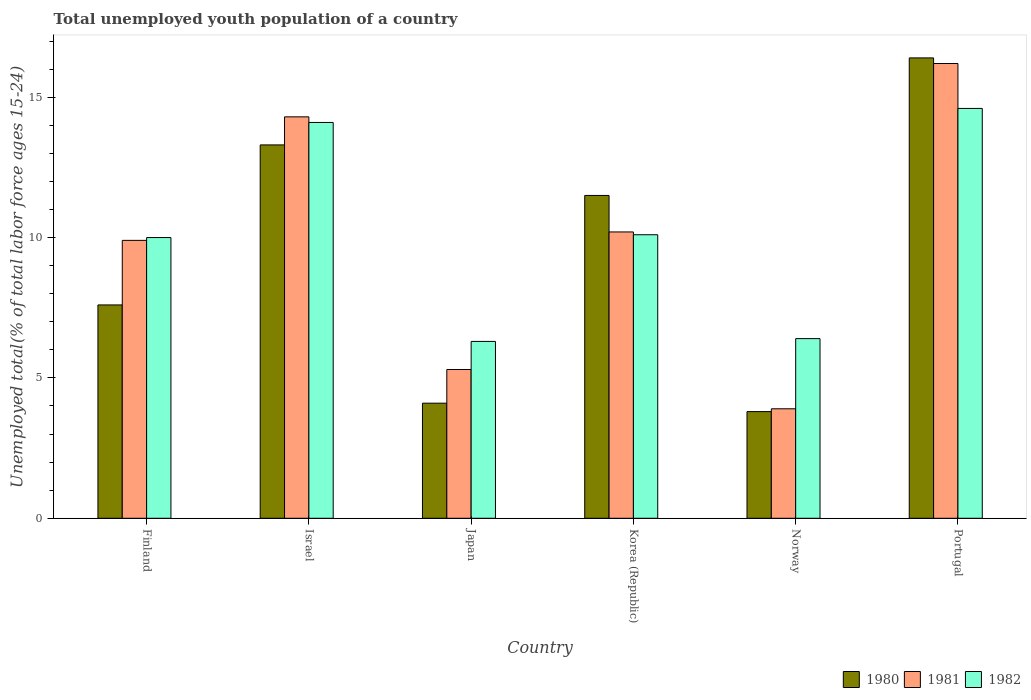How many different coloured bars are there?
Offer a terse response. 3. Are the number of bars on each tick of the X-axis equal?
Offer a terse response. Yes. How many bars are there on the 5th tick from the left?
Your answer should be very brief. 3. How many bars are there on the 1st tick from the right?
Your response must be concise. 3. What is the label of the 2nd group of bars from the left?
Provide a short and direct response. Israel. In how many cases, is the number of bars for a given country not equal to the number of legend labels?
Make the answer very short. 0. What is the percentage of total unemployed youth population of a country in 1982 in Norway?
Offer a terse response. 6.4. Across all countries, what is the maximum percentage of total unemployed youth population of a country in 1981?
Your answer should be compact. 16.2. Across all countries, what is the minimum percentage of total unemployed youth population of a country in 1981?
Your answer should be compact. 3.9. In which country was the percentage of total unemployed youth population of a country in 1980 maximum?
Provide a short and direct response. Portugal. What is the total percentage of total unemployed youth population of a country in 1980 in the graph?
Offer a very short reply. 56.7. What is the difference between the percentage of total unemployed youth population of a country in 1980 in Finland and that in Japan?
Give a very brief answer. 3.5. What is the difference between the percentage of total unemployed youth population of a country in 1980 in Norway and the percentage of total unemployed youth population of a country in 1982 in Portugal?
Make the answer very short. -10.8. What is the average percentage of total unemployed youth population of a country in 1982 per country?
Ensure brevity in your answer.  10.25. What is the difference between the percentage of total unemployed youth population of a country of/in 1982 and percentage of total unemployed youth population of a country of/in 1980 in Portugal?
Give a very brief answer. -1.8. In how many countries, is the percentage of total unemployed youth population of a country in 1981 greater than 1 %?
Offer a very short reply. 6. What is the ratio of the percentage of total unemployed youth population of a country in 1981 in Finland to that in Japan?
Provide a short and direct response. 1.87. Is the difference between the percentage of total unemployed youth population of a country in 1982 in Finland and Portugal greater than the difference between the percentage of total unemployed youth population of a country in 1980 in Finland and Portugal?
Make the answer very short. Yes. What is the difference between the highest and the second highest percentage of total unemployed youth population of a country in 1980?
Give a very brief answer. 4.9. What is the difference between the highest and the lowest percentage of total unemployed youth population of a country in 1981?
Provide a short and direct response. 12.3. In how many countries, is the percentage of total unemployed youth population of a country in 1980 greater than the average percentage of total unemployed youth population of a country in 1980 taken over all countries?
Your answer should be very brief. 3. What does the 1st bar from the left in Japan represents?
Keep it short and to the point. 1980. Is it the case that in every country, the sum of the percentage of total unemployed youth population of a country in 1982 and percentage of total unemployed youth population of a country in 1980 is greater than the percentage of total unemployed youth population of a country in 1981?
Your answer should be compact. Yes. How many bars are there?
Your answer should be very brief. 18. How many countries are there in the graph?
Keep it short and to the point. 6. Does the graph contain grids?
Provide a succinct answer. No. How many legend labels are there?
Offer a very short reply. 3. How are the legend labels stacked?
Offer a terse response. Horizontal. What is the title of the graph?
Provide a succinct answer. Total unemployed youth population of a country. Does "1990" appear as one of the legend labels in the graph?
Your answer should be very brief. No. What is the label or title of the Y-axis?
Ensure brevity in your answer.  Unemployed total(% of total labor force ages 15-24). What is the Unemployed total(% of total labor force ages 15-24) in 1980 in Finland?
Give a very brief answer. 7.6. What is the Unemployed total(% of total labor force ages 15-24) in 1981 in Finland?
Provide a succinct answer. 9.9. What is the Unemployed total(% of total labor force ages 15-24) in 1982 in Finland?
Give a very brief answer. 10. What is the Unemployed total(% of total labor force ages 15-24) in 1980 in Israel?
Your answer should be very brief. 13.3. What is the Unemployed total(% of total labor force ages 15-24) of 1981 in Israel?
Provide a short and direct response. 14.3. What is the Unemployed total(% of total labor force ages 15-24) in 1982 in Israel?
Provide a short and direct response. 14.1. What is the Unemployed total(% of total labor force ages 15-24) in 1980 in Japan?
Offer a terse response. 4.1. What is the Unemployed total(% of total labor force ages 15-24) of 1981 in Japan?
Ensure brevity in your answer.  5.3. What is the Unemployed total(% of total labor force ages 15-24) in 1982 in Japan?
Provide a short and direct response. 6.3. What is the Unemployed total(% of total labor force ages 15-24) in 1980 in Korea (Republic)?
Keep it short and to the point. 11.5. What is the Unemployed total(% of total labor force ages 15-24) in 1981 in Korea (Republic)?
Provide a short and direct response. 10.2. What is the Unemployed total(% of total labor force ages 15-24) in 1982 in Korea (Republic)?
Your response must be concise. 10.1. What is the Unemployed total(% of total labor force ages 15-24) in 1980 in Norway?
Your answer should be compact. 3.8. What is the Unemployed total(% of total labor force ages 15-24) in 1981 in Norway?
Make the answer very short. 3.9. What is the Unemployed total(% of total labor force ages 15-24) in 1982 in Norway?
Your answer should be very brief. 6.4. What is the Unemployed total(% of total labor force ages 15-24) of 1980 in Portugal?
Ensure brevity in your answer.  16.4. What is the Unemployed total(% of total labor force ages 15-24) of 1981 in Portugal?
Your answer should be compact. 16.2. What is the Unemployed total(% of total labor force ages 15-24) of 1982 in Portugal?
Offer a very short reply. 14.6. Across all countries, what is the maximum Unemployed total(% of total labor force ages 15-24) of 1980?
Your answer should be very brief. 16.4. Across all countries, what is the maximum Unemployed total(% of total labor force ages 15-24) in 1981?
Ensure brevity in your answer.  16.2. Across all countries, what is the maximum Unemployed total(% of total labor force ages 15-24) in 1982?
Keep it short and to the point. 14.6. Across all countries, what is the minimum Unemployed total(% of total labor force ages 15-24) in 1980?
Your answer should be compact. 3.8. Across all countries, what is the minimum Unemployed total(% of total labor force ages 15-24) in 1981?
Your answer should be very brief. 3.9. Across all countries, what is the minimum Unemployed total(% of total labor force ages 15-24) of 1982?
Offer a very short reply. 6.3. What is the total Unemployed total(% of total labor force ages 15-24) in 1980 in the graph?
Offer a terse response. 56.7. What is the total Unemployed total(% of total labor force ages 15-24) of 1981 in the graph?
Give a very brief answer. 59.8. What is the total Unemployed total(% of total labor force ages 15-24) in 1982 in the graph?
Your response must be concise. 61.5. What is the difference between the Unemployed total(% of total labor force ages 15-24) of 1980 in Finland and that in Israel?
Provide a short and direct response. -5.7. What is the difference between the Unemployed total(% of total labor force ages 15-24) of 1980 in Finland and that in Japan?
Give a very brief answer. 3.5. What is the difference between the Unemployed total(% of total labor force ages 15-24) of 1981 in Finland and that in Japan?
Make the answer very short. 4.6. What is the difference between the Unemployed total(% of total labor force ages 15-24) of 1982 in Finland and that in Japan?
Keep it short and to the point. 3.7. What is the difference between the Unemployed total(% of total labor force ages 15-24) in 1981 in Finland and that in Norway?
Your answer should be compact. 6. What is the difference between the Unemployed total(% of total labor force ages 15-24) in 1980 in Finland and that in Portugal?
Your answer should be very brief. -8.8. What is the difference between the Unemployed total(% of total labor force ages 15-24) in 1980 in Israel and that in Japan?
Keep it short and to the point. 9.2. What is the difference between the Unemployed total(% of total labor force ages 15-24) in 1981 in Israel and that in Japan?
Your response must be concise. 9. What is the difference between the Unemployed total(% of total labor force ages 15-24) in 1980 in Israel and that in Korea (Republic)?
Make the answer very short. 1.8. What is the difference between the Unemployed total(% of total labor force ages 15-24) of 1982 in Israel and that in Korea (Republic)?
Provide a short and direct response. 4. What is the difference between the Unemployed total(% of total labor force ages 15-24) in 1980 in Israel and that in Norway?
Give a very brief answer. 9.5. What is the difference between the Unemployed total(% of total labor force ages 15-24) of 1981 in Israel and that in Norway?
Ensure brevity in your answer.  10.4. What is the difference between the Unemployed total(% of total labor force ages 15-24) of 1982 in Israel and that in Norway?
Make the answer very short. 7.7. What is the difference between the Unemployed total(% of total labor force ages 15-24) of 1980 in Japan and that in Korea (Republic)?
Provide a succinct answer. -7.4. What is the difference between the Unemployed total(% of total labor force ages 15-24) in 1981 in Japan and that in Korea (Republic)?
Offer a terse response. -4.9. What is the difference between the Unemployed total(% of total labor force ages 15-24) in 1982 in Japan and that in Korea (Republic)?
Offer a very short reply. -3.8. What is the difference between the Unemployed total(% of total labor force ages 15-24) in 1980 in Japan and that in Portugal?
Keep it short and to the point. -12.3. What is the difference between the Unemployed total(% of total labor force ages 15-24) of 1982 in Japan and that in Portugal?
Provide a short and direct response. -8.3. What is the difference between the Unemployed total(% of total labor force ages 15-24) in 1981 in Korea (Republic) and that in Norway?
Make the answer very short. 6.3. What is the difference between the Unemployed total(% of total labor force ages 15-24) of 1982 in Korea (Republic) and that in Portugal?
Your answer should be very brief. -4.5. What is the difference between the Unemployed total(% of total labor force ages 15-24) in 1980 in Norway and that in Portugal?
Make the answer very short. -12.6. What is the difference between the Unemployed total(% of total labor force ages 15-24) of 1981 in Norway and that in Portugal?
Give a very brief answer. -12.3. What is the difference between the Unemployed total(% of total labor force ages 15-24) in 1980 in Finland and the Unemployed total(% of total labor force ages 15-24) in 1981 in Israel?
Give a very brief answer. -6.7. What is the difference between the Unemployed total(% of total labor force ages 15-24) in 1981 in Finland and the Unemployed total(% of total labor force ages 15-24) in 1982 in Israel?
Your answer should be very brief. -4.2. What is the difference between the Unemployed total(% of total labor force ages 15-24) in 1980 in Finland and the Unemployed total(% of total labor force ages 15-24) in 1981 in Japan?
Offer a very short reply. 2.3. What is the difference between the Unemployed total(% of total labor force ages 15-24) in 1981 in Finland and the Unemployed total(% of total labor force ages 15-24) in 1982 in Japan?
Your answer should be compact. 3.6. What is the difference between the Unemployed total(% of total labor force ages 15-24) of 1980 in Finland and the Unemployed total(% of total labor force ages 15-24) of 1981 in Korea (Republic)?
Offer a very short reply. -2.6. What is the difference between the Unemployed total(% of total labor force ages 15-24) of 1980 in Finland and the Unemployed total(% of total labor force ages 15-24) of 1982 in Korea (Republic)?
Make the answer very short. -2.5. What is the difference between the Unemployed total(% of total labor force ages 15-24) in 1980 in Finland and the Unemployed total(% of total labor force ages 15-24) in 1982 in Norway?
Keep it short and to the point. 1.2. What is the difference between the Unemployed total(% of total labor force ages 15-24) of 1981 in Finland and the Unemployed total(% of total labor force ages 15-24) of 1982 in Norway?
Offer a very short reply. 3.5. What is the difference between the Unemployed total(% of total labor force ages 15-24) in 1981 in Finland and the Unemployed total(% of total labor force ages 15-24) in 1982 in Portugal?
Your answer should be very brief. -4.7. What is the difference between the Unemployed total(% of total labor force ages 15-24) in 1980 in Israel and the Unemployed total(% of total labor force ages 15-24) in 1981 in Japan?
Your answer should be very brief. 8. What is the difference between the Unemployed total(% of total labor force ages 15-24) of 1980 in Israel and the Unemployed total(% of total labor force ages 15-24) of 1982 in Japan?
Provide a succinct answer. 7. What is the difference between the Unemployed total(% of total labor force ages 15-24) of 1980 in Israel and the Unemployed total(% of total labor force ages 15-24) of 1981 in Korea (Republic)?
Keep it short and to the point. 3.1. What is the difference between the Unemployed total(% of total labor force ages 15-24) of 1980 in Israel and the Unemployed total(% of total labor force ages 15-24) of 1982 in Korea (Republic)?
Offer a terse response. 3.2. What is the difference between the Unemployed total(% of total labor force ages 15-24) in 1980 in Israel and the Unemployed total(% of total labor force ages 15-24) in 1981 in Portugal?
Keep it short and to the point. -2.9. What is the difference between the Unemployed total(% of total labor force ages 15-24) of 1980 in Japan and the Unemployed total(% of total labor force ages 15-24) of 1982 in Korea (Republic)?
Make the answer very short. -6. What is the difference between the Unemployed total(% of total labor force ages 15-24) in 1981 in Japan and the Unemployed total(% of total labor force ages 15-24) in 1982 in Korea (Republic)?
Make the answer very short. -4.8. What is the difference between the Unemployed total(% of total labor force ages 15-24) in 1980 in Japan and the Unemployed total(% of total labor force ages 15-24) in 1981 in Norway?
Offer a terse response. 0.2. What is the difference between the Unemployed total(% of total labor force ages 15-24) of 1981 in Japan and the Unemployed total(% of total labor force ages 15-24) of 1982 in Norway?
Provide a short and direct response. -1.1. What is the difference between the Unemployed total(% of total labor force ages 15-24) of 1980 in Japan and the Unemployed total(% of total labor force ages 15-24) of 1981 in Portugal?
Offer a terse response. -12.1. What is the difference between the Unemployed total(% of total labor force ages 15-24) of 1980 in Japan and the Unemployed total(% of total labor force ages 15-24) of 1982 in Portugal?
Offer a terse response. -10.5. What is the difference between the Unemployed total(% of total labor force ages 15-24) of 1980 in Korea (Republic) and the Unemployed total(% of total labor force ages 15-24) of 1981 in Norway?
Your answer should be very brief. 7.6. What is the difference between the Unemployed total(% of total labor force ages 15-24) in 1980 in Korea (Republic) and the Unemployed total(% of total labor force ages 15-24) in 1982 in Norway?
Offer a very short reply. 5.1. What is the difference between the Unemployed total(% of total labor force ages 15-24) in 1980 in Norway and the Unemployed total(% of total labor force ages 15-24) in 1981 in Portugal?
Make the answer very short. -12.4. What is the difference between the Unemployed total(% of total labor force ages 15-24) of 1980 in Norway and the Unemployed total(% of total labor force ages 15-24) of 1982 in Portugal?
Your response must be concise. -10.8. What is the average Unemployed total(% of total labor force ages 15-24) in 1980 per country?
Offer a terse response. 9.45. What is the average Unemployed total(% of total labor force ages 15-24) of 1981 per country?
Your answer should be very brief. 9.97. What is the average Unemployed total(% of total labor force ages 15-24) of 1982 per country?
Your answer should be compact. 10.25. What is the difference between the Unemployed total(% of total labor force ages 15-24) in 1980 and Unemployed total(% of total labor force ages 15-24) in 1982 in Finland?
Your response must be concise. -2.4. What is the difference between the Unemployed total(% of total labor force ages 15-24) of 1980 and Unemployed total(% of total labor force ages 15-24) of 1981 in Israel?
Your response must be concise. -1. What is the difference between the Unemployed total(% of total labor force ages 15-24) of 1980 and Unemployed total(% of total labor force ages 15-24) of 1982 in Israel?
Offer a very short reply. -0.8. What is the difference between the Unemployed total(% of total labor force ages 15-24) of 1981 and Unemployed total(% of total labor force ages 15-24) of 1982 in Israel?
Your answer should be compact. 0.2. What is the difference between the Unemployed total(% of total labor force ages 15-24) in 1981 and Unemployed total(% of total labor force ages 15-24) in 1982 in Japan?
Provide a short and direct response. -1. What is the difference between the Unemployed total(% of total labor force ages 15-24) of 1980 and Unemployed total(% of total labor force ages 15-24) of 1981 in Korea (Republic)?
Make the answer very short. 1.3. What is the difference between the Unemployed total(% of total labor force ages 15-24) of 1981 and Unemployed total(% of total labor force ages 15-24) of 1982 in Korea (Republic)?
Your answer should be compact. 0.1. What is the difference between the Unemployed total(% of total labor force ages 15-24) in 1980 and Unemployed total(% of total labor force ages 15-24) in 1982 in Norway?
Your answer should be very brief. -2.6. What is the difference between the Unemployed total(% of total labor force ages 15-24) of 1981 and Unemployed total(% of total labor force ages 15-24) of 1982 in Portugal?
Make the answer very short. 1.6. What is the ratio of the Unemployed total(% of total labor force ages 15-24) of 1981 in Finland to that in Israel?
Ensure brevity in your answer.  0.69. What is the ratio of the Unemployed total(% of total labor force ages 15-24) in 1982 in Finland to that in Israel?
Your answer should be very brief. 0.71. What is the ratio of the Unemployed total(% of total labor force ages 15-24) of 1980 in Finland to that in Japan?
Keep it short and to the point. 1.85. What is the ratio of the Unemployed total(% of total labor force ages 15-24) of 1981 in Finland to that in Japan?
Ensure brevity in your answer.  1.87. What is the ratio of the Unemployed total(% of total labor force ages 15-24) of 1982 in Finland to that in Japan?
Offer a terse response. 1.59. What is the ratio of the Unemployed total(% of total labor force ages 15-24) in 1980 in Finland to that in Korea (Republic)?
Provide a short and direct response. 0.66. What is the ratio of the Unemployed total(% of total labor force ages 15-24) in 1981 in Finland to that in Korea (Republic)?
Make the answer very short. 0.97. What is the ratio of the Unemployed total(% of total labor force ages 15-24) of 1980 in Finland to that in Norway?
Make the answer very short. 2. What is the ratio of the Unemployed total(% of total labor force ages 15-24) in 1981 in Finland to that in Norway?
Your answer should be compact. 2.54. What is the ratio of the Unemployed total(% of total labor force ages 15-24) of 1982 in Finland to that in Norway?
Your answer should be compact. 1.56. What is the ratio of the Unemployed total(% of total labor force ages 15-24) of 1980 in Finland to that in Portugal?
Your response must be concise. 0.46. What is the ratio of the Unemployed total(% of total labor force ages 15-24) in 1981 in Finland to that in Portugal?
Ensure brevity in your answer.  0.61. What is the ratio of the Unemployed total(% of total labor force ages 15-24) of 1982 in Finland to that in Portugal?
Your answer should be very brief. 0.68. What is the ratio of the Unemployed total(% of total labor force ages 15-24) in 1980 in Israel to that in Japan?
Keep it short and to the point. 3.24. What is the ratio of the Unemployed total(% of total labor force ages 15-24) in 1981 in Israel to that in Japan?
Provide a succinct answer. 2.7. What is the ratio of the Unemployed total(% of total labor force ages 15-24) in 1982 in Israel to that in Japan?
Offer a terse response. 2.24. What is the ratio of the Unemployed total(% of total labor force ages 15-24) of 1980 in Israel to that in Korea (Republic)?
Provide a short and direct response. 1.16. What is the ratio of the Unemployed total(% of total labor force ages 15-24) of 1981 in Israel to that in Korea (Republic)?
Provide a succinct answer. 1.4. What is the ratio of the Unemployed total(% of total labor force ages 15-24) of 1982 in Israel to that in Korea (Republic)?
Keep it short and to the point. 1.4. What is the ratio of the Unemployed total(% of total labor force ages 15-24) of 1980 in Israel to that in Norway?
Ensure brevity in your answer.  3.5. What is the ratio of the Unemployed total(% of total labor force ages 15-24) of 1981 in Israel to that in Norway?
Ensure brevity in your answer.  3.67. What is the ratio of the Unemployed total(% of total labor force ages 15-24) in 1982 in Israel to that in Norway?
Ensure brevity in your answer.  2.2. What is the ratio of the Unemployed total(% of total labor force ages 15-24) of 1980 in Israel to that in Portugal?
Provide a short and direct response. 0.81. What is the ratio of the Unemployed total(% of total labor force ages 15-24) in 1981 in Israel to that in Portugal?
Give a very brief answer. 0.88. What is the ratio of the Unemployed total(% of total labor force ages 15-24) of 1982 in Israel to that in Portugal?
Provide a short and direct response. 0.97. What is the ratio of the Unemployed total(% of total labor force ages 15-24) of 1980 in Japan to that in Korea (Republic)?
Your response must be concise. 0.36. What is the ratio of the Unemployed total(% of total labor force ages 15-24) of 1981 in Japan to that in Korea (Republic)?
Give a very brief answer. 0.52. What is the ratio of the Unemployed total(% of total labor force ages 15-24) of 1982 in Japan to that in Korea (Republic)?
Make the answer very short. 0.62. What is the ratio of the Unemployed total(% of total labor force ages 15-24) of 1980 in Japan to that in Norway?
Make the answer very short. 1.08. What is the ratio of the Unemployed total(% of total labor force ages 15-24) in 1981 in Japan to that in Norway?
Make the answer very short. 1.36. What is the ratio of the Unemployed total(% of total labor force ages 15-24) in 1982 in Japan to that in Norway?
Make the answer very short. 0.98. What is the ratio of the Unemployed total(% of total labor force ages 15-24) of 1981 in Japan to that in Portugal?
Offer a terse response. 0.33. What is the ratio of the Unemployed total(% of total labor force ages 15-24) in 1982 in Japan to that in Portugal?
Ensure brevity in your answer.  0.43. What is the ratio of the Unemployed total(% of total labor force ages 15-24) of 1980 in Korea (Republic) to that in Norway?
Keep it short and to the point. 3.03. What is the ratio of the Unemployed total(% of total labor force ages 15-24) of 1981 in Korea (Republic) to that in Norway?
Your answer should be compact. 2.62. What is the ratio of the Unemployed total(% of total labor force ages 15-24) in 1982 in Korea (Republic) to that in Norway?
Provide a short and direct response. 1.58. What is the ratio of the Unemployed total(% of total labor force ages 15-24) of 1980 in Korea (Republic) to that in Portugal?
Keep it short and to the point. 0.7. What is the ratio of the Unemployed total(% of total labor force ages 15-24) in 1981 in Korea (Republic) to that in Portugal?
Your response must be concise. 0.63. What is the ratio of the Unemployed total(% of total labor force ages 15-24) in 1982 in Korea (Republic) to that in Portugal?
Ensure brevity in your answer.  0.69. What is the ratio of the Unemployed total(% of total labor force ages 15-24) in 1980 in Norway to that in Portugal?
Your response must be concise. 0.23. What is the ratio of the Unemployed total(% of total labor force ages 15-24) of 1981 in Norway to that in Portugal?
Keep it short and to the point. 0.24. What is the ratio of the Unemployed total(% of total labor force ages 15-24) in 1982 in Norway to that in Portugal?
Offer a very short reply. 0.44. What is the difference between the highest and the lowest Unemployed total(% of total labor force ages 15-24) in 1980?
Give a very brief answer. 12.6. 